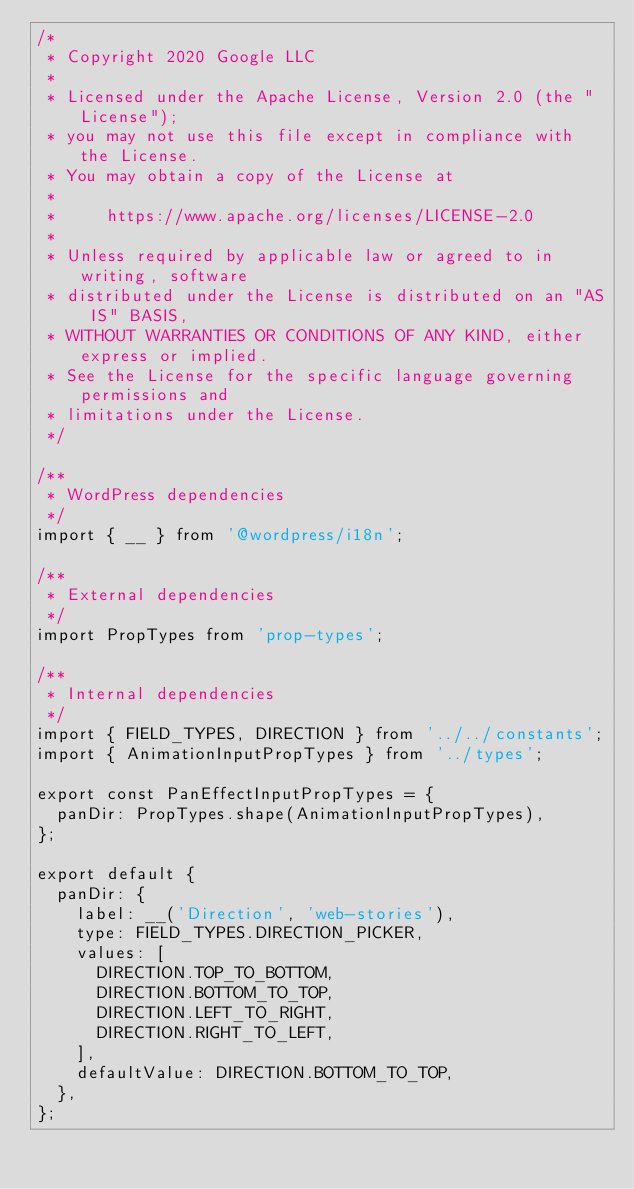Convert code to text. <code><loc_0><loc_0><loc_500><loc_500><_JavaScript_>/*
 * Copyright 2020 Google LLC
 *
 * Licensed under the Apache License, Version 2.0 (the "License");
 * you may not use this file except in compliance with the License.
 * You may obtain a copy of the License at
 *
 *     https://www.apache.org/licenses/LICENSE-2.0
 *
 * Unless required by applicable law or agreed to in writing, software
 * distributed under the License is distributed on an "AS IS" BASIS,
 * WITHOUT WARRANTIES OR CONDITIONS OF ANY KIND, either express or implied.
 * See the License for the specific language governing permissions and
 * limitations under the License.
 */

/**
 * WordPress dependencies
 */
import { __ } from '@wordpress/i18n';

/**
 * External dependencies
 */
import PropTypes from 'prop-types';

/**
 * Internal dependencies
 */
import { FIELD_TYPES, DIRECTION } from '../../constants';
import { AnimationInputPropTypes } from '../types';

export const PanEffectInputPropTypes = {
  panDir: PropTypes.shape(AnimationInputPropTypes),
};

export default {
  panDir: {
    label: __('Direction', 'web-stories'),
    type: FIELD_TYPES.DIRECTION_PICKER,
    values: [
      DIRECTION.TOP_TO_BOTTOM,
      DIRECTION.BOTTOM_TO_TOP,
      DIRECTION.LEFT_TO_RIGHT,
      DIRECTION.RIGHT_TO_LEFT,
    ],
    defaultValue: DIRECTION.BOTTOM_TO_TOP,
  },
};
</code> 